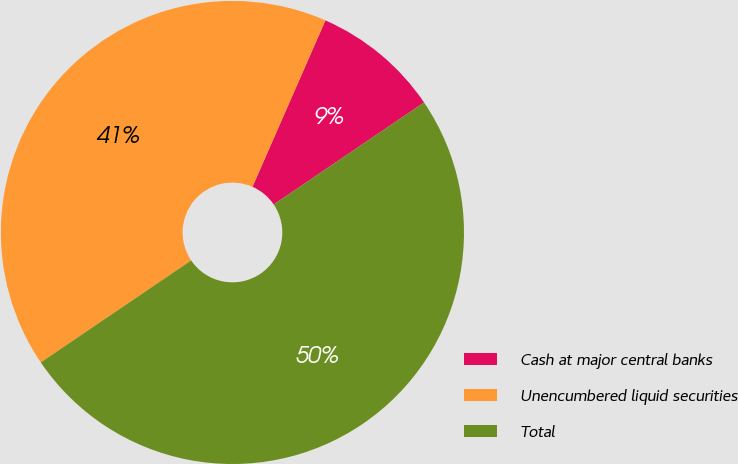Convert chart to OTSL. <chart><loc_0><loc_0><loc_500><loc_500><pie_chart><fcel>Cash at major central banks<fcel>Unencumbered liquid securities<fcel>Total<nl><fcel>8.94%<fcel>41.06%<fcel>50.0%<nl></chart> 